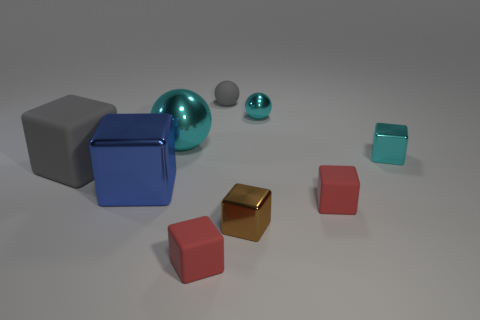Can you describe the lighting and atmosphere of this scene? The scene is illuminated with soft, diffuse light, creating gentle shadows and giving the image a calm, serene atmosphere. The lack of harsh shadows suggests an ambient light source, possibly out of frame, which creates an even and balanced lighting environment that is pleasing to the eye. 